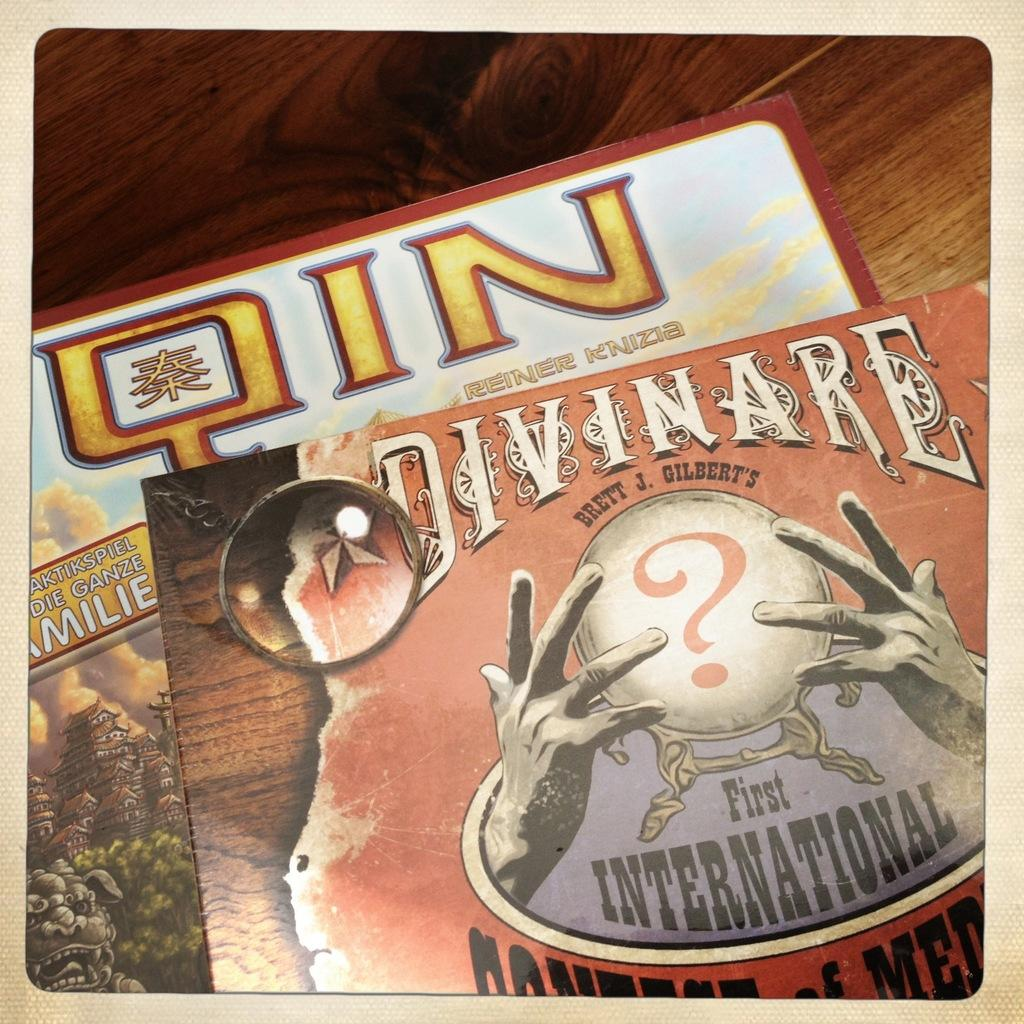<image>
Present a compact description of the photo's key features. wooden surface with several books on it including Qin and Divinare 